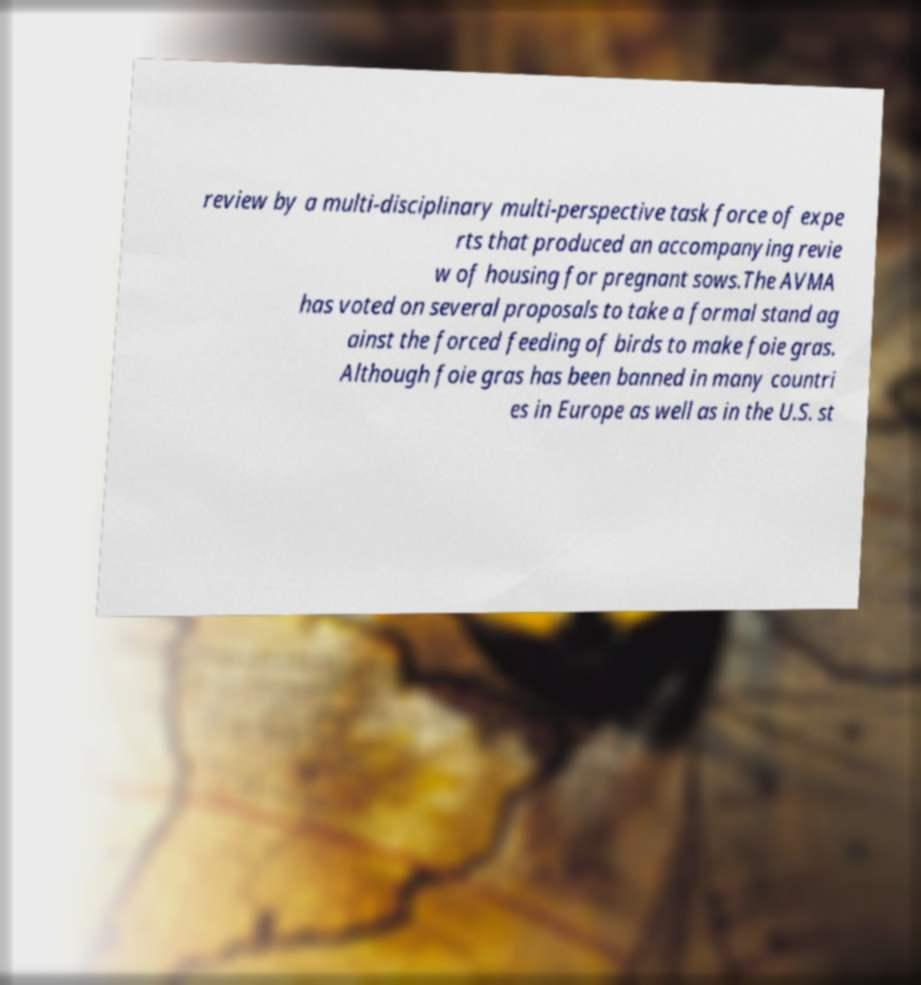Could you assist in decoding the text presented in this image and type it out clearly? review by a multi-disciplinary multi-perspective task force of expe rts that produced an accompanying revie w of housing for pregnant sows.The AVMA has voted on several proposals to take a formal stand ag ainst the forced feeding of birds to make foie gras. Although foie gras has been banned in many countri es in Europe as well as in the U.S. st 